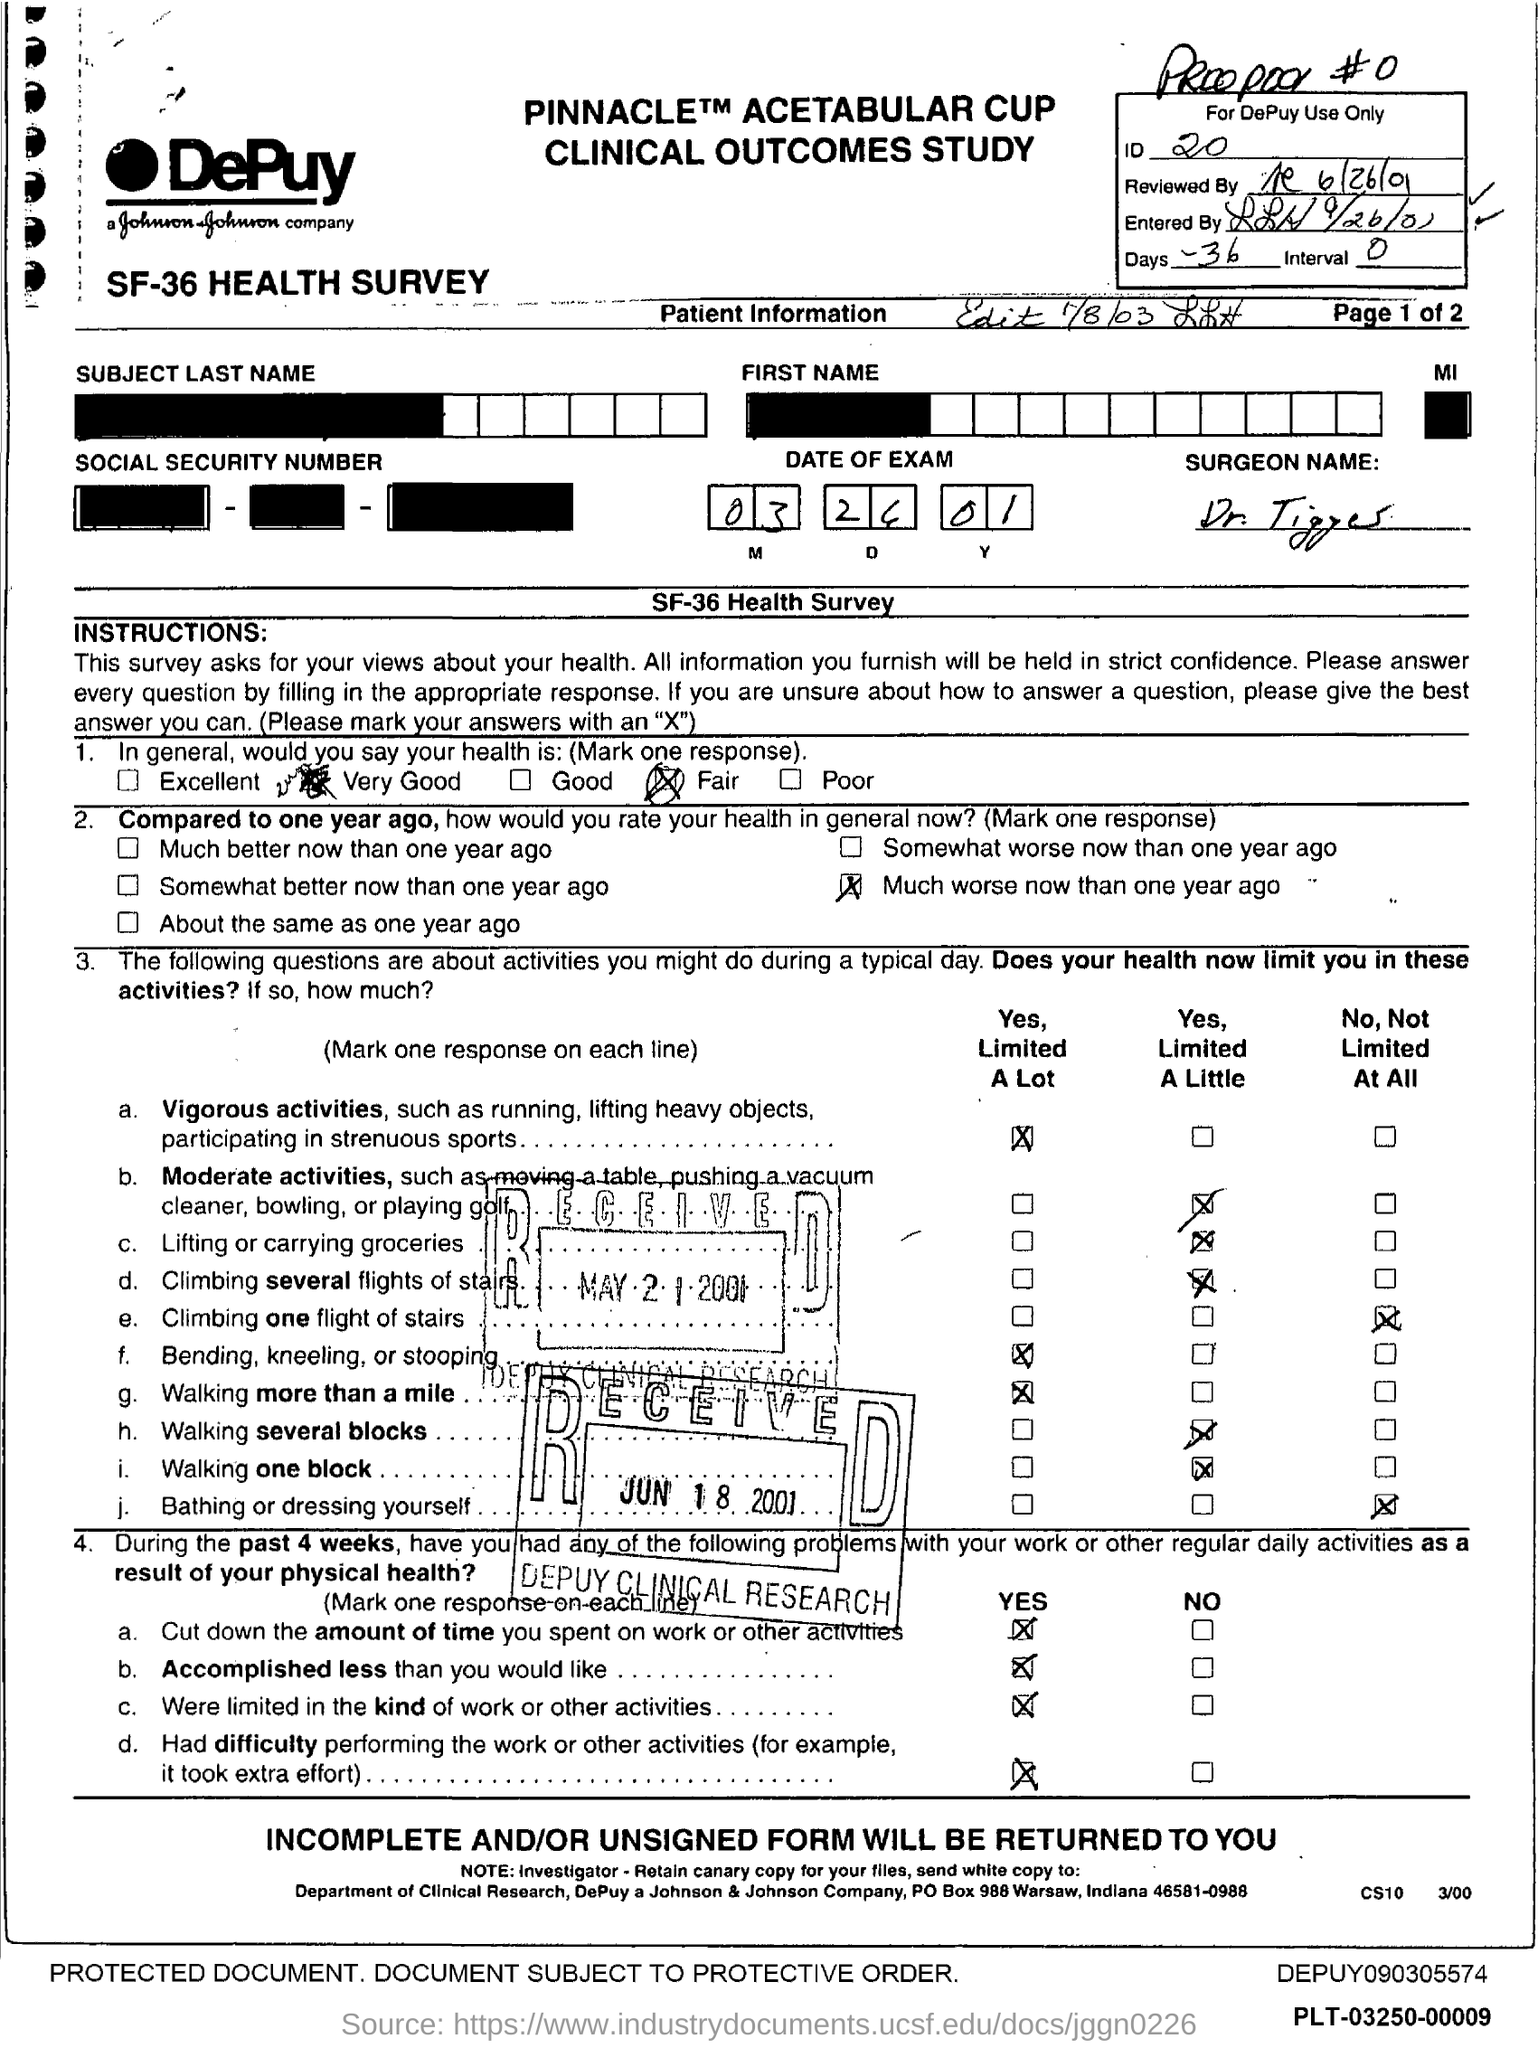Give some essential details in this illustration. The Interval is a range of values from 0 to... 